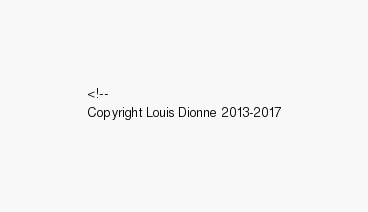Convert code to text. <code><loc_0><loc_0><loc_500><loc_500><_HTML_><!--
Copyright Louis Dionne 2013-2017</code> 